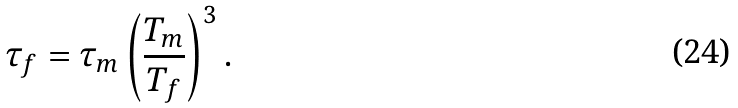<formula> <loc_0><loc_0><loc_500><loc_500>\tau _ { f } = \tau _ { m } \left ( \frac { T _ { m } } { T _ { f } } \right ) ^ { 3 } .</formula> 